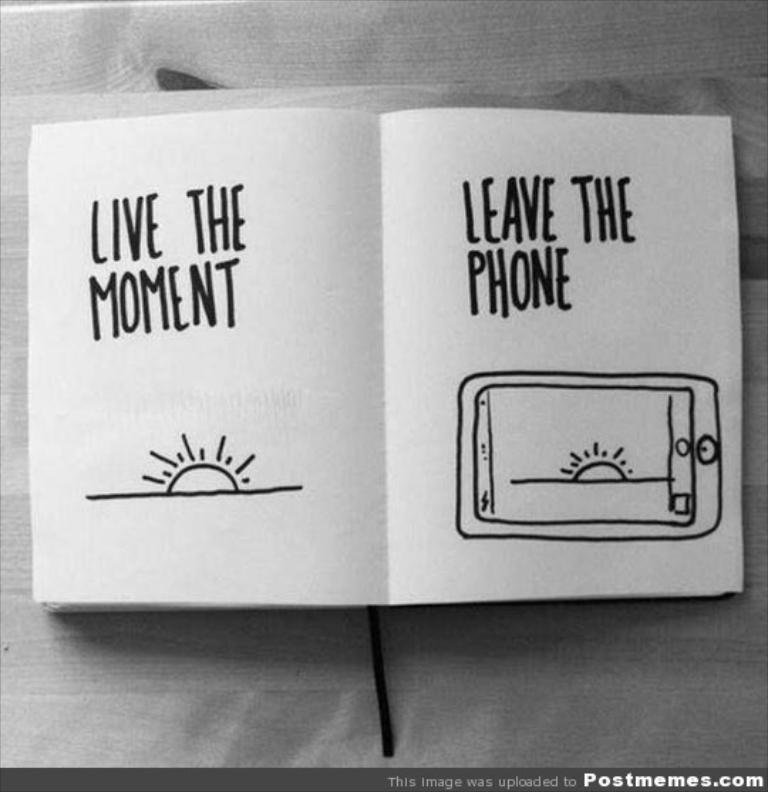Provide a one-sentence caption for the provided image. A book open, and on the pages it says Live the Moment. 